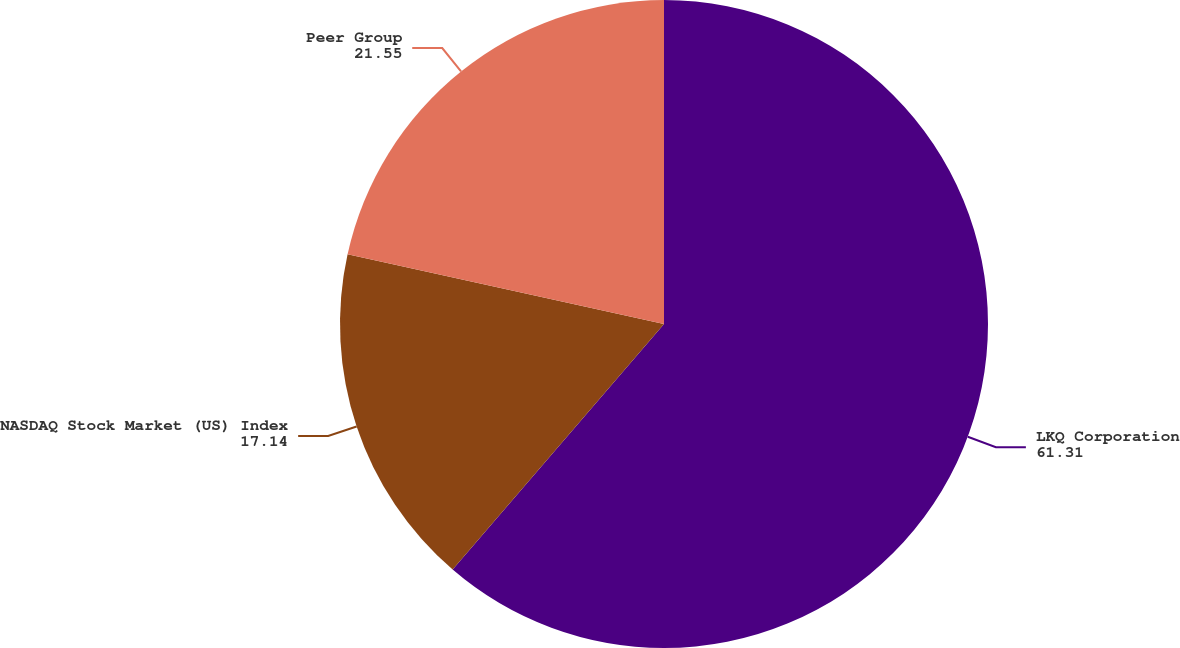Convert chart to OTSL. <chart><loc_0><loc_0><loc_500><loc_500><pie_chart><fcel>LKQ Corporation<fcel>NASDAQ Stock Market (US) Index<fcel>Peer Group<nl><fcel>61.31%<fcel>17.14%<fcel>21.55%<nl></chart> 